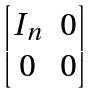<formula> <loc_0><loc_0><loc_500><loc_500>\begin{bmatrix} I _ { n } & 0 \\ 0 & 0 \end{bmatrix}</formula> 